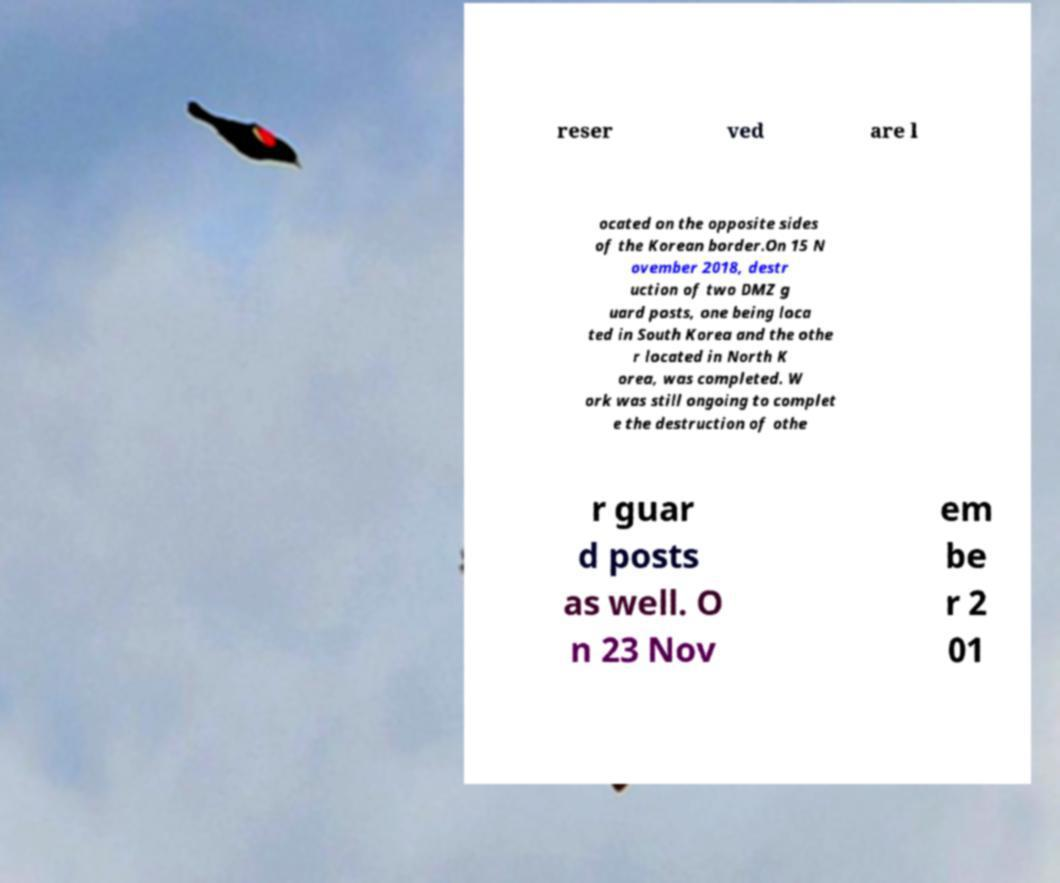Please identify and transcribe the text found in this image. reser ved are l ocated on the opposite sides of the Korean border.On 15 N ovember 2018, destr uction of two DMZ g uard posts, one being loca ted in South Korea and the othe r located in North K orea, was completed. W ork was still ongoing to complet e the destruction of othe r guar d posts as well. O n 23 Nov em be r 2 01 